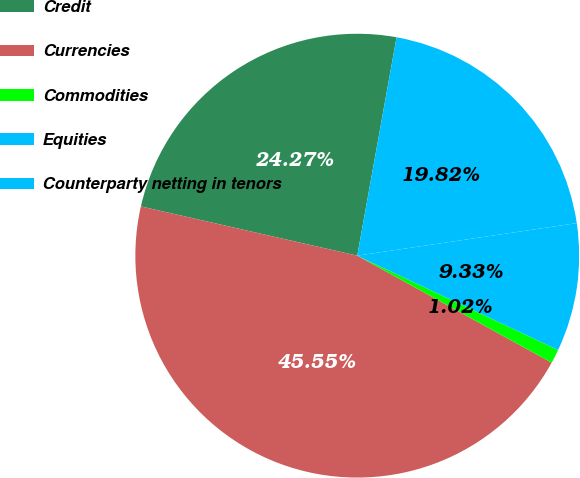Convert chart. <chart><loc_0><loc_0><loc_500><loc_500><pie_chart><fcel>Credit<fcel>Currencies<fcel>Commodities<fcel>Equities<fcel>Counterparty netting in tenors<nl><fcel>24.27%<fcel>45.55%<fcel>1.02%<fcel>9.33%<fcel>19.82%<nl></chart> 